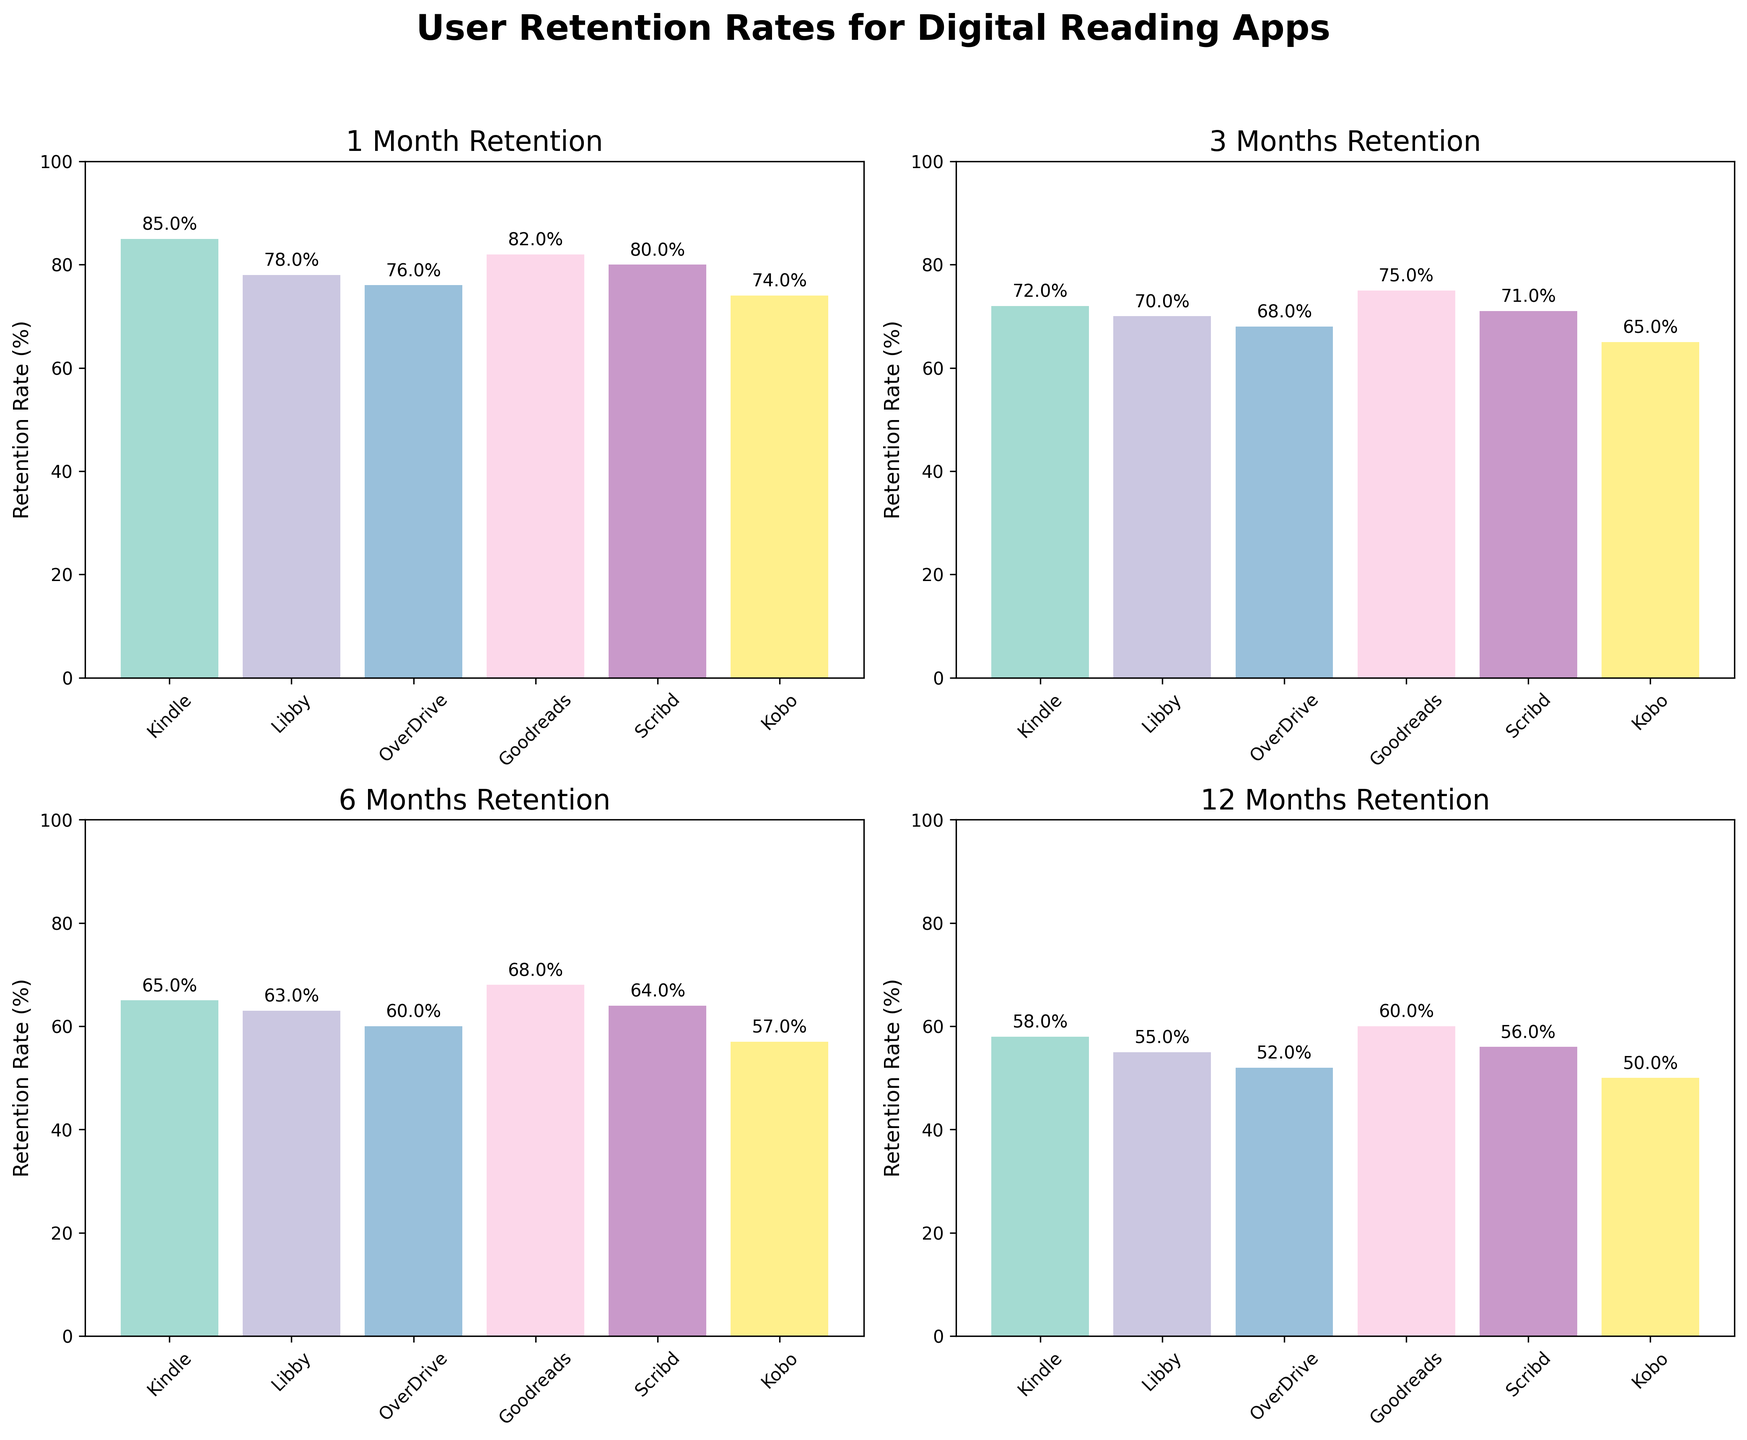How many different digital reading apps are compared in the figure? Count the number of different app names listed on the x-axis of any bar plot. There are 6 different apps: Kindle, Libby, OverDrive, Goodreads, Scribd, and Kobo.
Answer: 6 What is the title of the figure comparing the retention rates? Read the title displayed at the top center of the figure. The title is "User Retention Rates for Digital Reading Apps".
Answer: User Retention Rates for Digital Reading Apps What is the highest retention rate at the 1-month period and which app does it belong to? Find the bar with the highest value in the subplot titled "1 Month Retention." The highest bar is for Kindle with 85%.
Answer: 85%, Kindle Which app shows the lowest retention rate at the 6-months period? Look at the subplot titled "6 Months Retention" and find the bar with the lowest value. Kobo has the lowest retention rate at 57%.
Answer: Kobo What is the average retention rate for GoodReads across all periods shown? Add up all the retention rates for GoodReads (82%, 75%, 68%, 60%) and divide by the number of periods (4). (82+75+68+60)/4 = 71.25.
Answer: 71.25% Comparing Scribd and Libby, which app retains more users after 12 months and by how much? Look at the subplot titled "12 Months Retention" and find the values for Scribd (56%) and Libby (55%). Scribd retains 1% more users than Libby.
Answer: Scribd by 1% Which app shows a consistent decrease in retention rates over all periods? Check each app across all subplots to see their retention rates decrease from 1-month to 12-months periods. All apps show a consistent decrease over all periods.
Answer: All apps What is the total retention rate for Kindle and Kobo at the 3-months period? Add the 3-months retention rates for Kindle (72%) and Kobo (65%). 72 + 65 = 137.
Answer: 137% Which app performs better at the 3-months period, OverDrive or Scribd? Compare the bar heights in the "3 Months Retention" subplot for OverDrive (68%) and Scribd (71%). Scribd performs better.
Answer: Scribd What is the difference in retention rate between the highest and lowest app at the 1-month period? Find the retention rates for the highest (Kindle, 85%) and lowest (Kobo, 74%) apps in the "1 Month Retention" subplot. Subtract the lowest from the highest (85 - 74 = 11).
Answer: 11% 